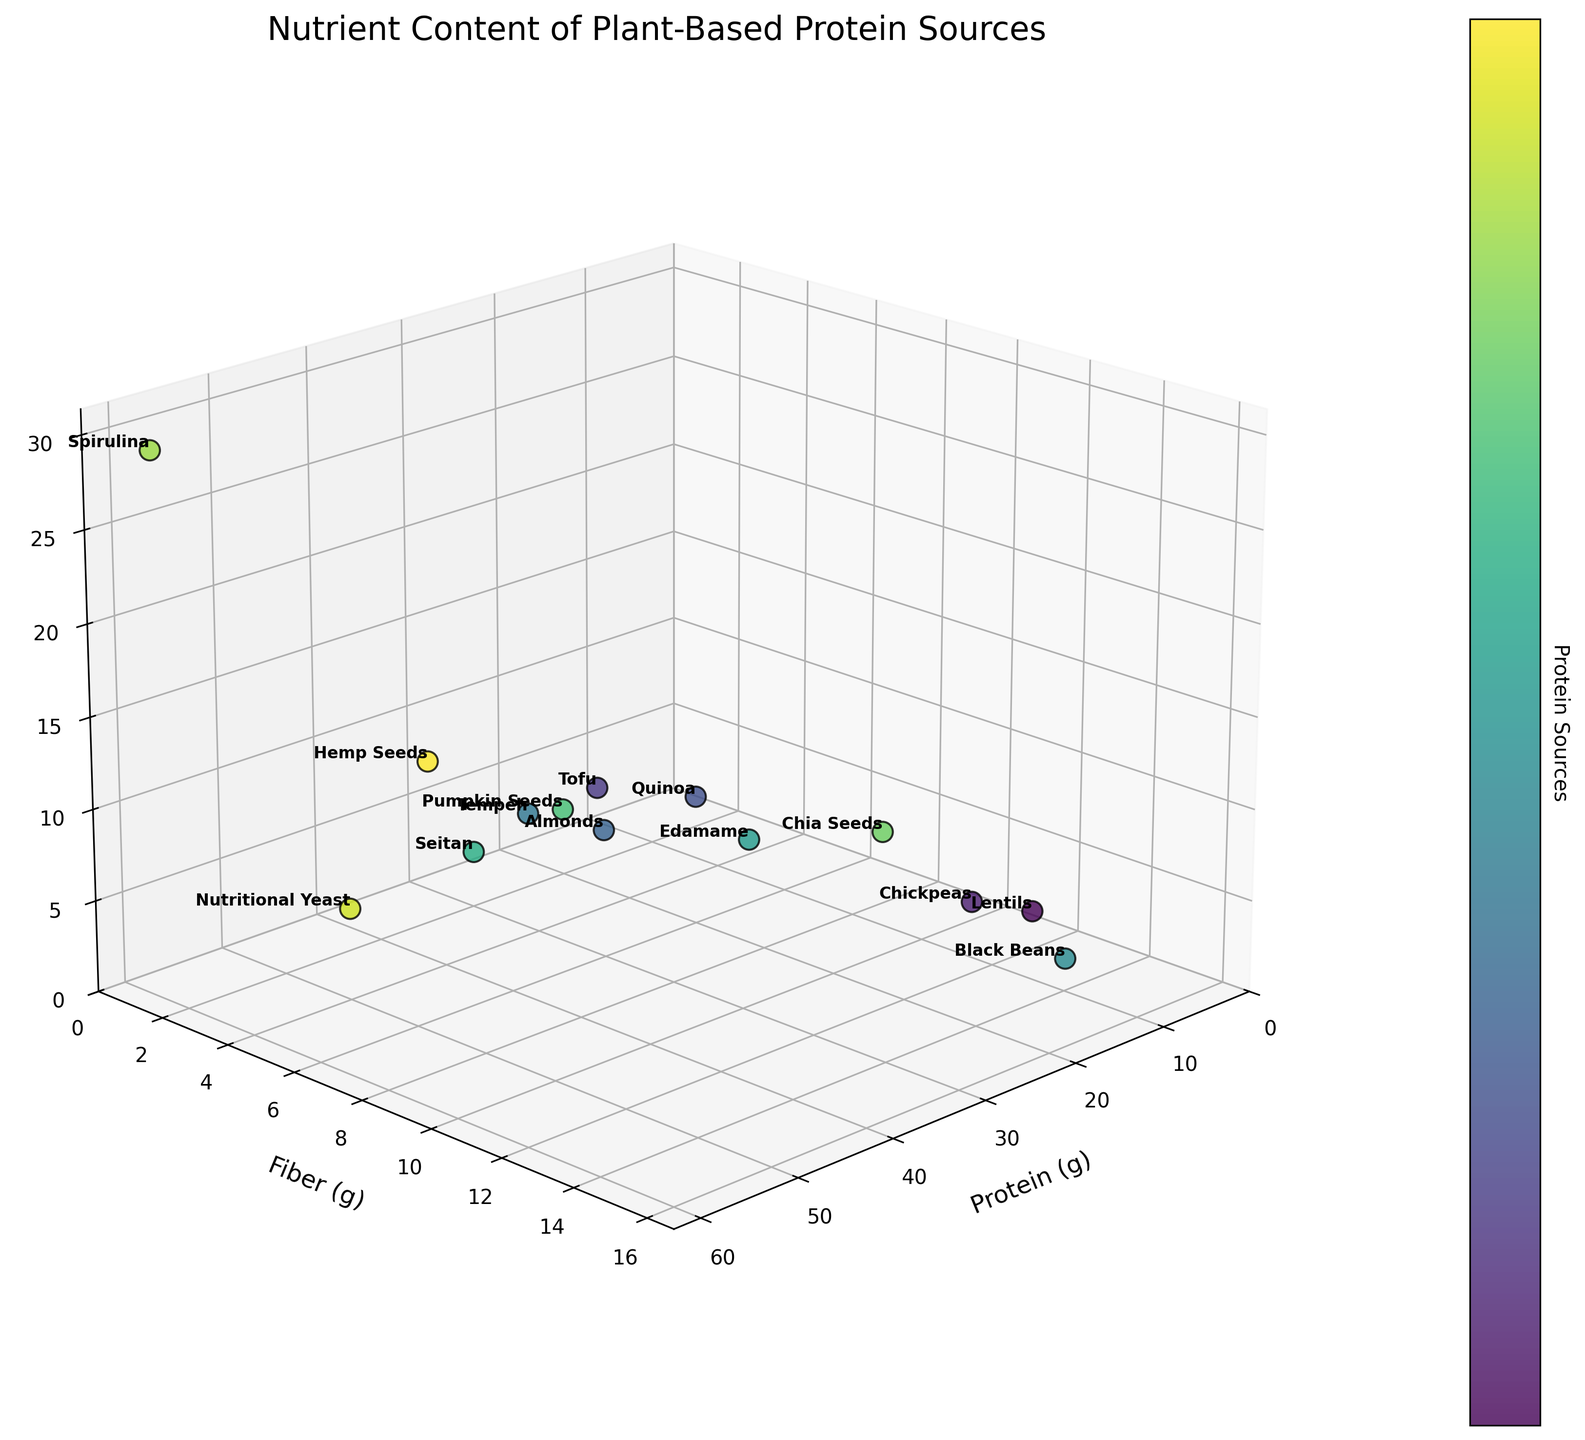What is the title of the 3D scatter plot? The title can be found at the top of the figure. It reads "Nutrient Content of Plant-Based Protein Sources"
Answer: Nutrient Content of Plant-Based Protein Sources How is the color of each data point determined? Each data point is colored according to its position in the list of protein sources, creating a gradient effect from one end of the list to the other.
Answer: Color gradient by protein source Which protein source has the highest protein content? The highest protein level can be found by looking at the data point that is farthest along the protein axis. Spirulina has the highest protein content at 57 grams.
Answer: Spirulina Which two protein sources have similar iron content but different fiber content? We need to look for data points with close z-axis values (iron) but with notably different y-axis values (fiber). Lentils and Chia Seeds both have a high iron content, but Lentils have 15g of fiber and Chia Seeds have 10.6g.
Answer: Lentils and Chia Seeds Which protein source has the lowest fiber content? The lowest fiber content is determined by the point closest to the origin on the fiber axis. Tofu has the lowest fiber content at 0.3 grams.
Answer: Tofu Which protein source provides the best combination of high protein and high fiber content? To find the best combination, look for a point high up on both the protein and fiber axes. Black Beans have a strong combination with 15g of protein and 15.2g of fiber.
Answer: Black Beans How many data points have higher iron content than 5 mg? Identify points that are above 5 mg on the iron (z-axis). Nutritional Yeast, Lentils, Hemp Seeds, Chia Seeds, and Spirulina meet this criterion, making a total of five.
Answer: 5 What range of protein content do Edamame and Seitan cover together? Check the protein axis for the range starting from Edamame's protein content (11g) to Seitan's (25g). The range is from 11g to 25g.
Answer: 11g to 25g If you were to pick a protein source with moderate levels of protein, fiber, and iron, which one would it be? Moderate levels can be considered values that are close to the middle range of each nutrient axis. Quinoa has 8g protein, 2.8g fiber, and 2.8mg iron, placing it close to the center.
Answer: Quinoa Which protein source has twice as much iron content as Pumpkin Seeds? Pumpkin Seeds have 3.3 mg of iron, so we need to find a point with approximately 6.6 mg of iron. Lentils have 6.6 mg of iron.
Answer: Lentils 